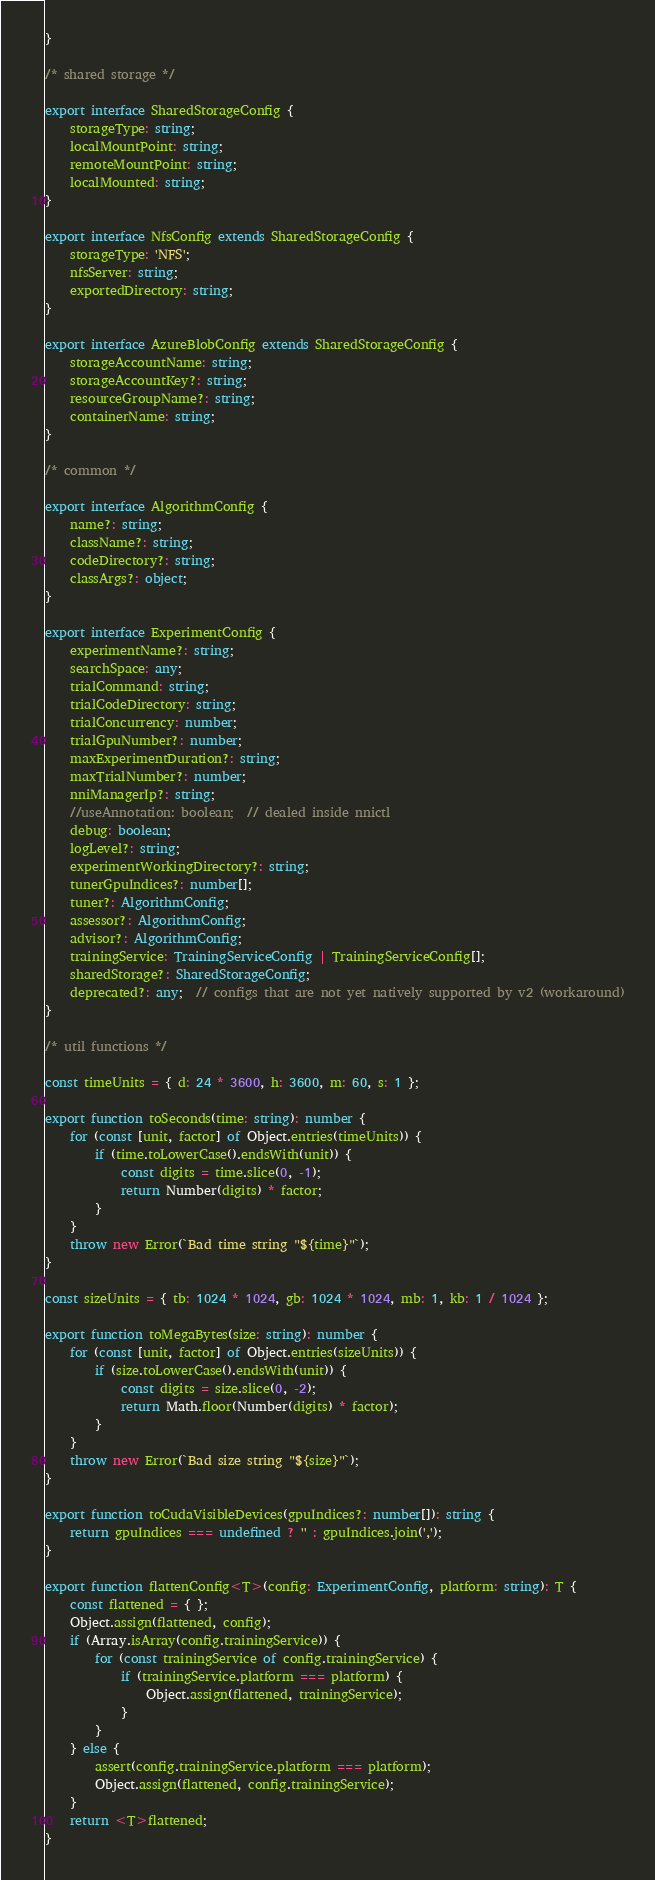<code> <loc_0><loc_0><loc_500><loc_500><_TypeScript_>}

/* shared storage */

export interface SharedStorageConfig {
    storageType: string;
    localMountPoint: string;
    remoteMountPoint: string;
    localMounted: string;
}

export interface NfsConfig extends SharedStorageConfig {
    storageType: 'NFS';
    nfsServer: string;
    exportedDirectory: string;
}

export interface AzureBlobConfig extends SharedStorageConfig {
    storageAccountName: string;
    storageAccountKey?: string;
    resourceGroupName?: string;
    containerName: string;
}

/* common */

export interface AlgorithmConfig {
    name?: string;
    className?: string;
    codeDirectory?: string;
    classArgs?: object;
}

export interface ExperimentConfig {
    experimentName?: string;
    searchSpace: any;
    trialCommand: string;
    trialCodeDirectory: string;
    trialConcurrency: number;
    trialGpuNumber?: number;
    maxExperimentDuration?: string;
    maxTrialNumber?: number;
    nniManagerIp?: string;
    //useAnnotation: boolean;  // dealed inside nnictl
    debug: boolean;
    logLevel?: string;
    experimentWorkingDirectory?: string;
    tunerGpuIndices?: number[];
    tuner?: AlgorithmConfig;
    assessor?: AlgorithmConfig;
    advisor?: AlgorithmConfig;
    trainingService: TrainingServiceConfig | TrainingServiceConfig[];
    sharedStorage?: SharedStorageConfig;
    deprecated?: any;  // configs that are not yet natively supported by v2 (workaround)
}

/* util functions */

const timeUnits = { d: 24 * 3600, h: 3600, m: 60, s: 1 };

export function toSeconds(time: string): number {
    for (const [unit, factor] of Object.entries(timeUnits)) {
        if (time.toLowerCase().endsWith(unit)) {
            const digits = time.slice(0, -1);
            return Number(digits) * factor;
        }
    }
    throw new Error(`Bad time string "${time}"`);
}

const sizeUnits = { tb: 1024 * 1024, gb: 1024 * 1024, mb: 1, kb: 1 / 1024 };

export function toMegaBytes(size: string): number {
    for (const [unit, factor] of Object.entries(sizeUnits)) {
        if (size.toLowerCase().endsWith(unit)) {
            const digits = size.slice(0, -2);
            return Math.floor(Number(digits) * factor);
        }
    }
    throw new Error(`Bad size string "${size}"`);
}

export function toCudaVisibleDevices(gpuIndices?: number[]): string {
    return gpuIndices === undefined ? '' : gpuIndices.join(',');
}

export function flattenConfig<T>(config: ExperimentConfig, platform: string): T {
    const flattened = { };
    Object.assign(flattened, config);
    if (Array.isArray(config.trainingService)) {
        for (const trainingService of config.trainingService) {
            if (trainingService.platform === platform) {
                Object.assign(flattened, trainingService);
            }
        }
    } else {
        assert(config.trainingService.platform === platform);
        Object.assign(flattened, config.trainingService);
    }
    return <T>flattened;
}
</code> 